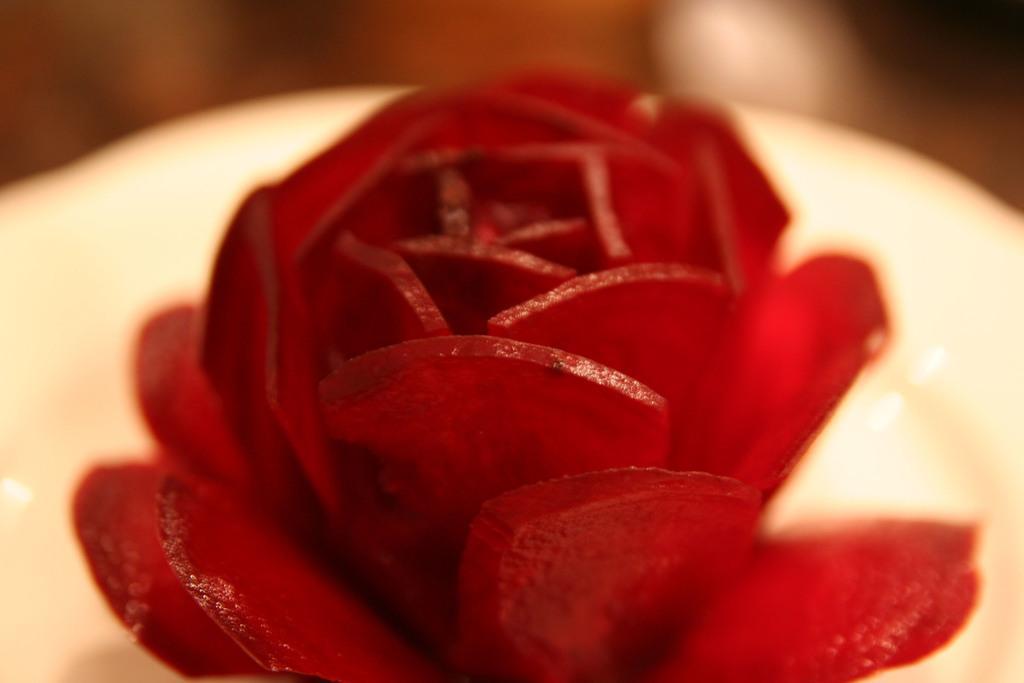In one or two sentences, can you explain what this image depicts? In this image I can see a beetroot which is sliced into the shape of a flower. I can see the blurry background which is cream and brown in color. 